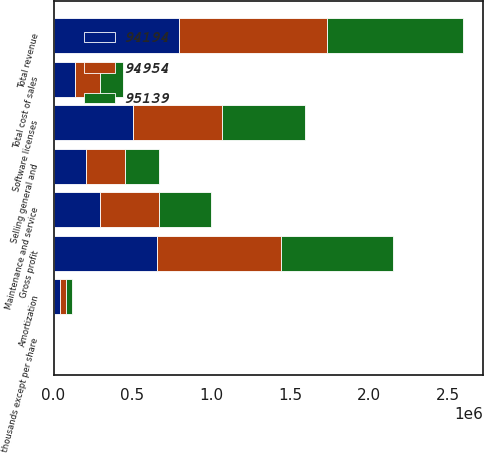<chart> <loc_0><loc_0><loc_500><loc_500><stacked_bar_chart><ecel><fcel>(in thousands except per share<fcel>Software licenses<fcel>Maintenance and service<fcel>Total revenue<fcel>Amortization<fcel>Total cost of sales<fcel>Gross profit<fcel>Selling general and<nl><fcel>94954<fcel>2014<fcel>564502<fcel>371519<fcel>936021<fcel>37653<fcel>153386<fcel>782635<fcel>246376<nl><fcel>95139<fcel>2013<fcel>528944<fcel>332316<fcel>861260<fcel>38298<fcel>146692<fcel>714568<fcel>218907<nl><fcel>94194<fcel>2012<fcel>501870<fcel>296148<fcel>798018<fcel>40889<fcel>139516<fcel>658502<fcel>205178<nl></chart> 